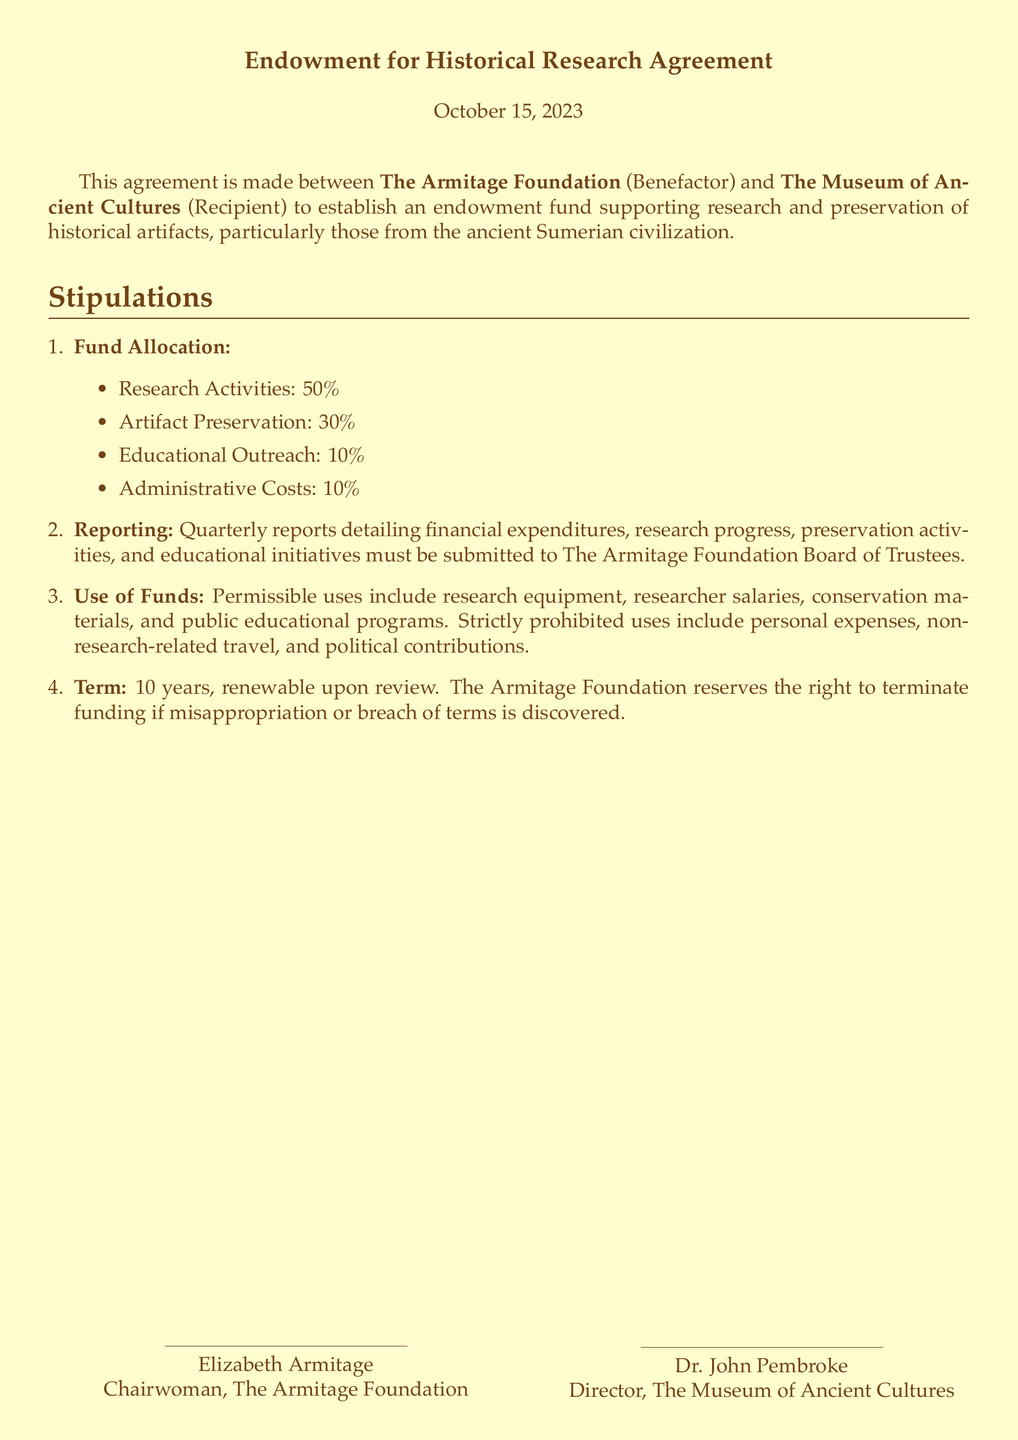What is the name of the benefactor? The benefactor named in the document is The Armitage Foundation.
Answer: The Armitage Foundation Who is the recipient of the endowment? The recipient mentioned in the document is The Museum of Ancient Cultures.
Answer: The Museum of Ancient Cultures What percentage of funds is allocated for Artifact Preservation? The document specifies that 30% of the funds is allocated for Artifact Preservation.
Answer: 30% How often must reports be submitted to the Board of Trustees? The agreement states that reports must be submitted quarterly.
Answer: Quarterly What is the term duration of the agreement? The term duration of the agreement is 10 years.
Answer: 10 years What is strictly prohibited from the use of funds? The document indicates that personal expenses are strictly prohibited from the use of the funds.
Answer: Personal expenses Under what condition can the Armitage Foundation terminate funding? The foundation can terminate the funding if misappropriation or breach of terms is discovered.
Answer: Misappropriation or breach of terms What is the percentage allocated for Educational Outreach? The document states that 10% of the funds is allocated for Educational Outreach.
Answer: 10% Who signed for The Armitage Foundation? Elizabeth Armitage signed for The Armitage Foundation as Chairwoman.
Answer: Elizabeth Armitage 